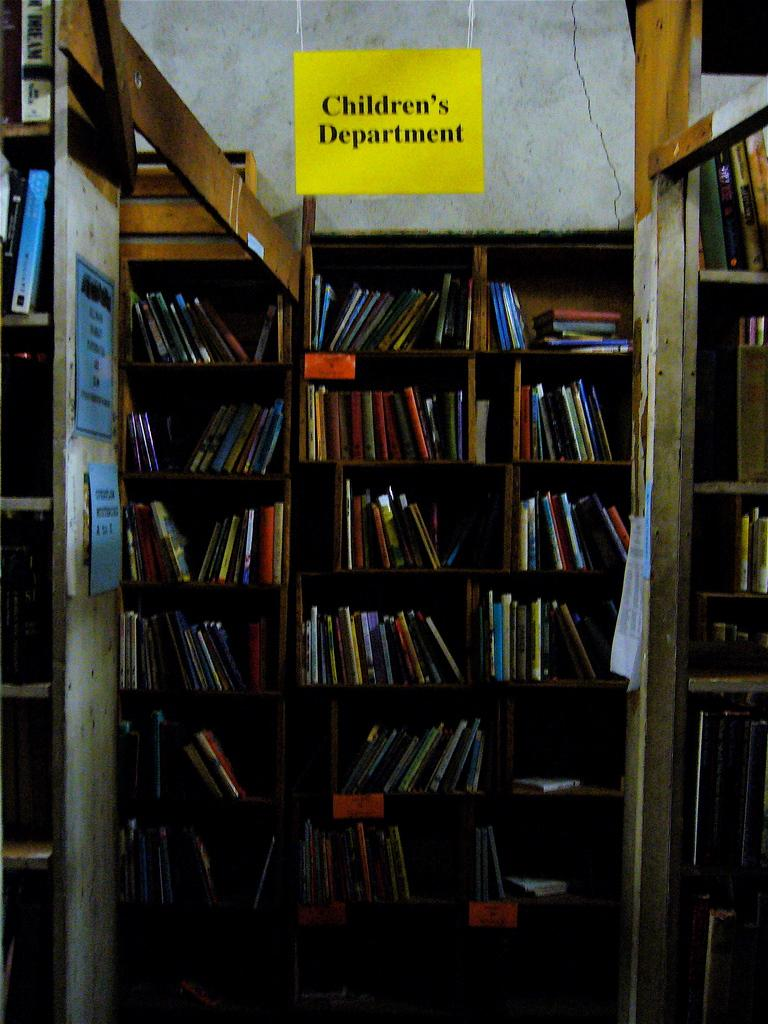<image>
Offer a succinct explanation of the picture presented. the bookcase is filled with a lot of books in a children section 